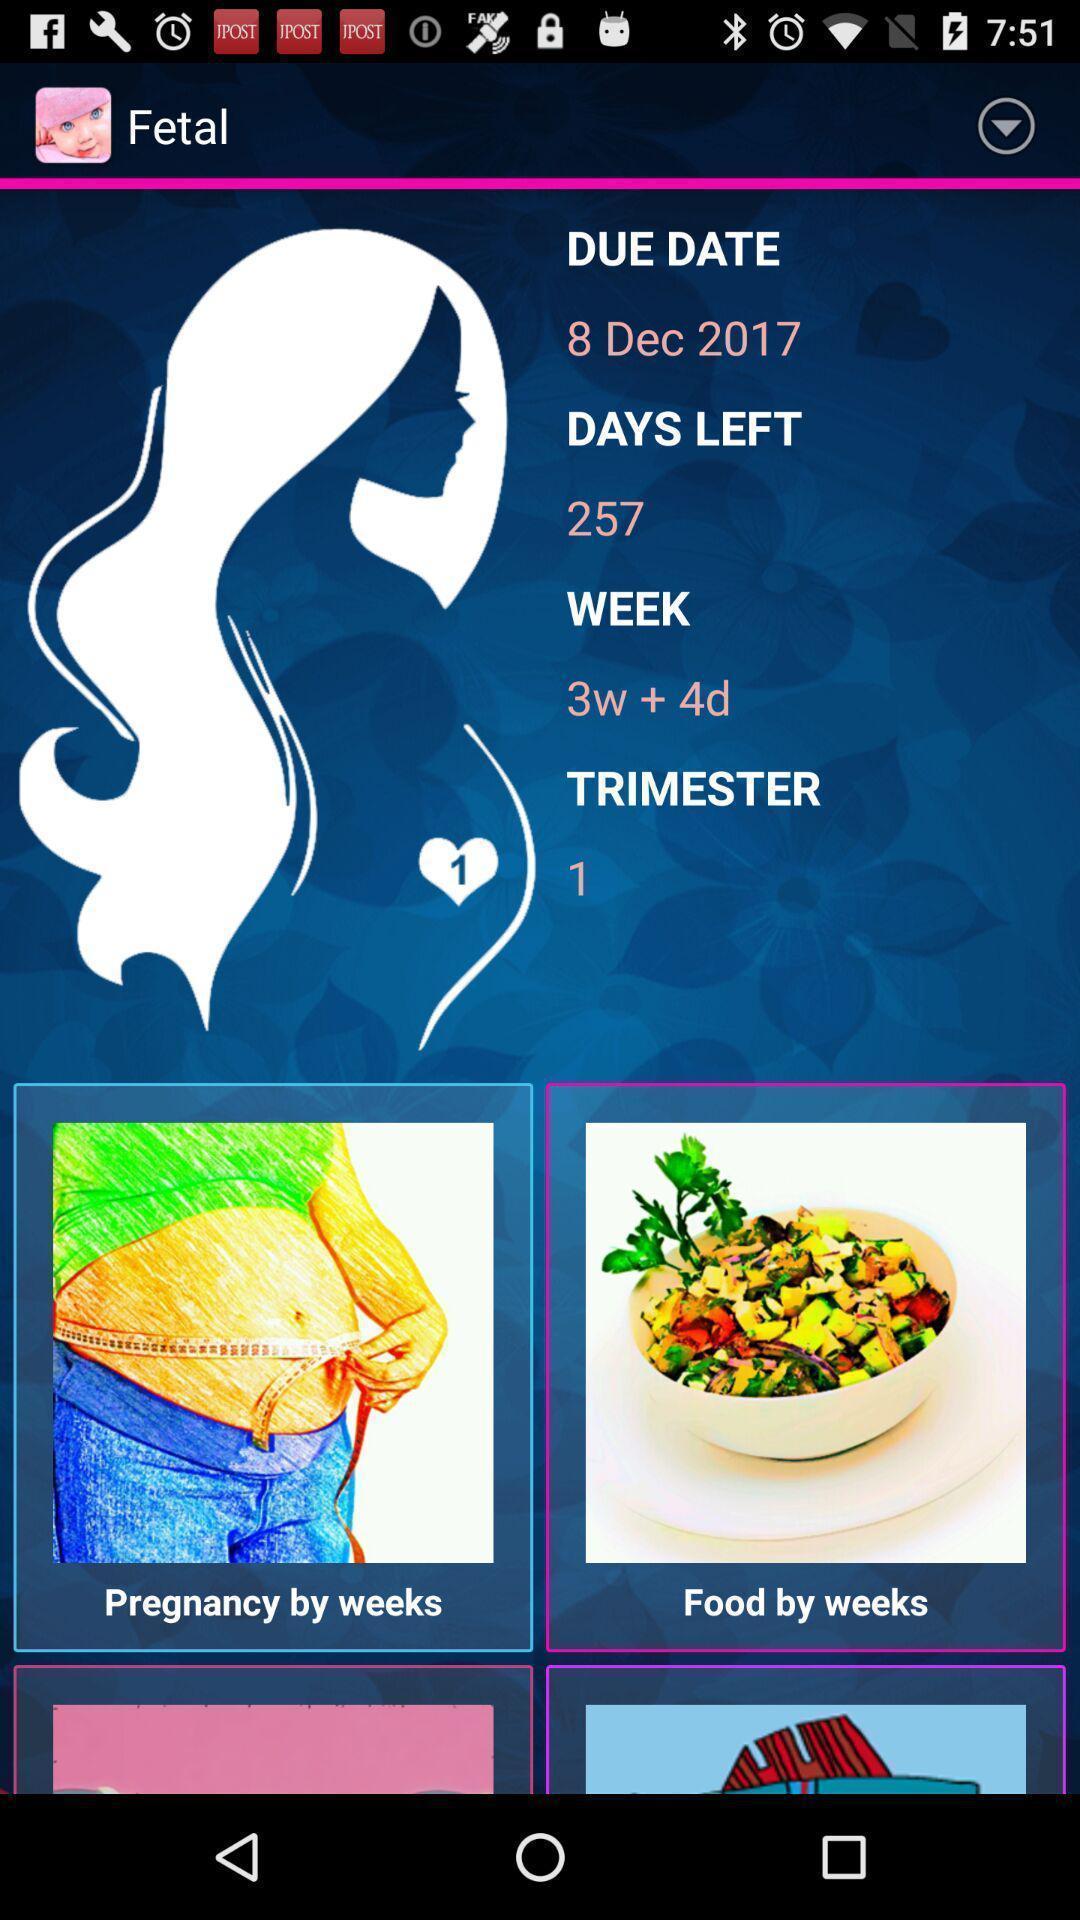Please provide a description for this image. Screen shows about a pregnancy app. 